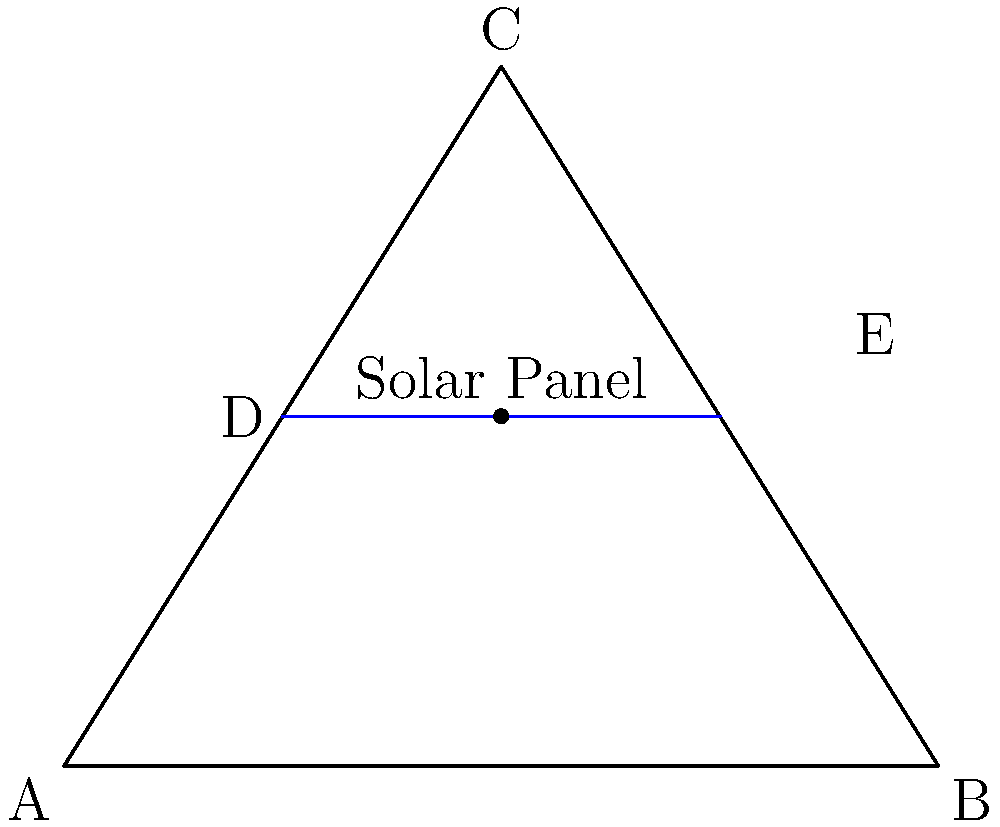A triangular drone wing has dimensions as shown in the diagram. To maximize energy capture, a solar panel needs to be installed parallel to the base of the triangle. If the solar panel's width is half the length of the base, what is the optimal height at which it should be placed to maximize its area? Let's approach this step-by-step:

1) The triangle's base (AB) is 10 units long, and its height (from C to AB) is 8 units.

2) The solar panel's width is half the base length, so it's 5 units.

3) Let's say the optimal height is $h$ units from the base.

4) The area of a rectangle (solar panel) is given by width * height.

5) Due to the properties of similar triangles, we can set up the following proportion:
   $\frac{10-5}{10} = \frac{8-h}{8}$

6) Simplifying: $\frac{1}{2} = \frac{8-h}{8}$

7) Solving for $h$:
   $8 - h = 4$
   $h = 4$

8) To confirm this is the maximum area, we can use calculus or check values above and below 4.

Therefore, the optimal height for the solar panel is 4 units from the base of the triangle.
Answer: 4 units from the base 